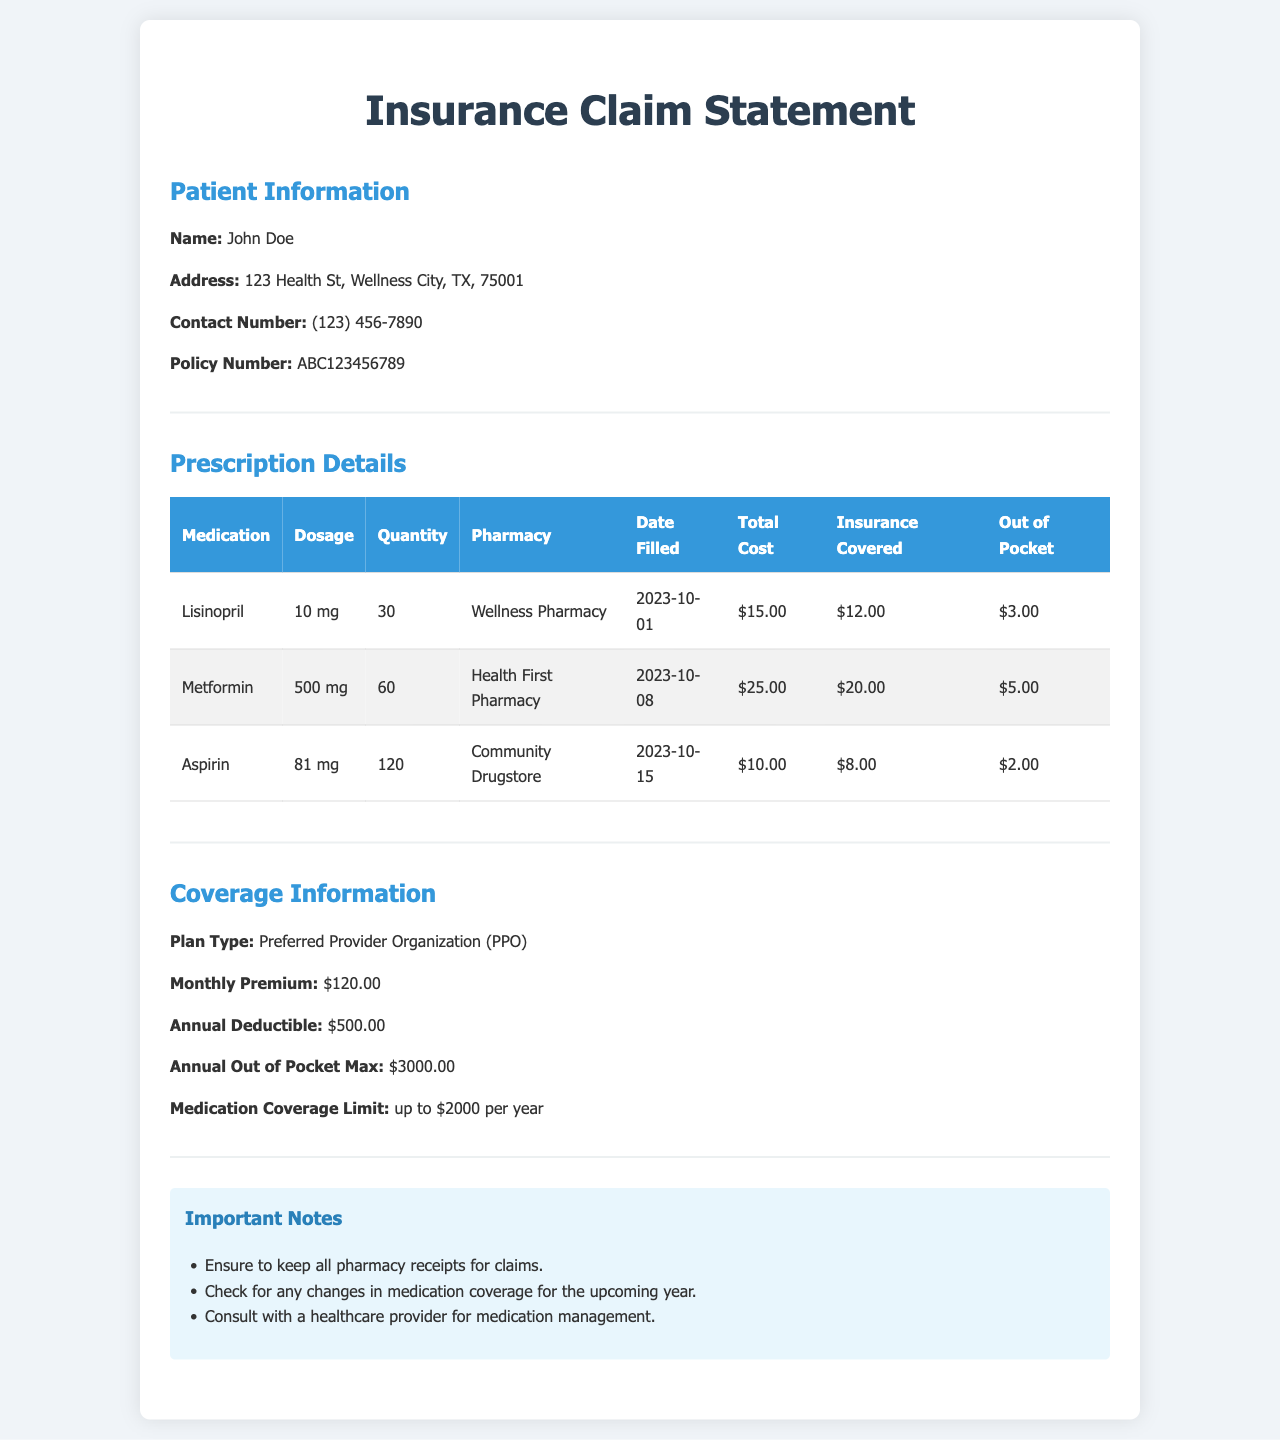What is the patient's name? The patient's name is stated in the Patient Information section.
Answer: John Doe What is the total cost for Metformin? The total cost for Metformin is provided in the Prescription Details section of the document.
Answer: $25.00 How much did the insurance cover for Lisinopril? The coverage for Lisinopril is listed in the Prescription Details table.
Answer: $12.00 What is the monthly premium for the insurance plan? The monthly premium is mentioned in the Coverage Information section.
Answer: $120.00 What is the annual out of pocket maximum? The out of pocket maximum is detailed in the Coverage Information section.
Answer: $3000.00 How much is the medication coverage limit per year? The medication coverage limit can be found in the Coverage Information section.
Answer: up to $2000 per year How many medications are listed in the Prescription Details? The number of medications is found by counting the rows under the Prescription Details table.
Answer: 3 What is the dosage of Aspirin? The dosage for Aspirin is specified in the Prescription Details table.
Answer: 81 mg What is one of the important notes mentioned? One important note is listed in the Important Notes section of the document.
Answer: Ensure to keep all pharmacy receipts for claims 